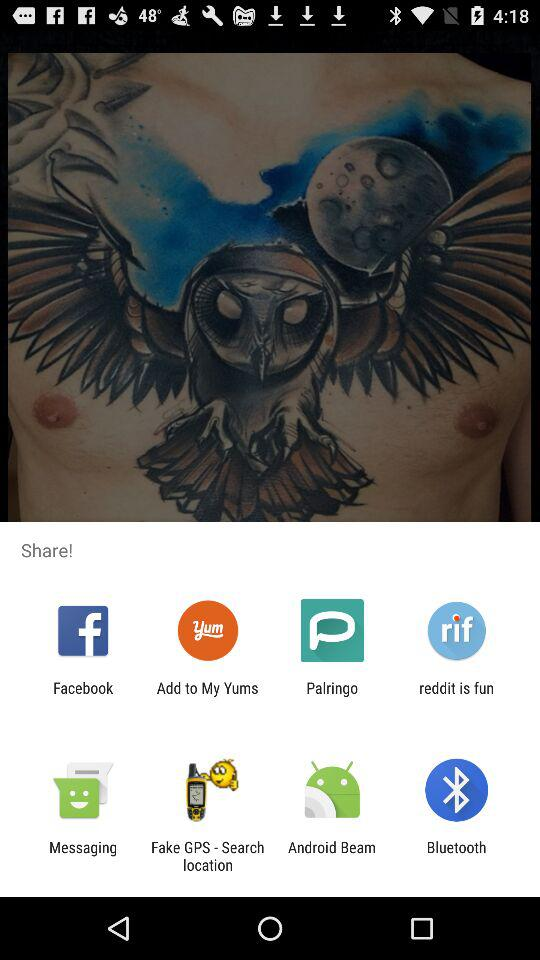Who is sharing the content?
When the provided information is insufficient, respond with <no answer>. <no answer> 